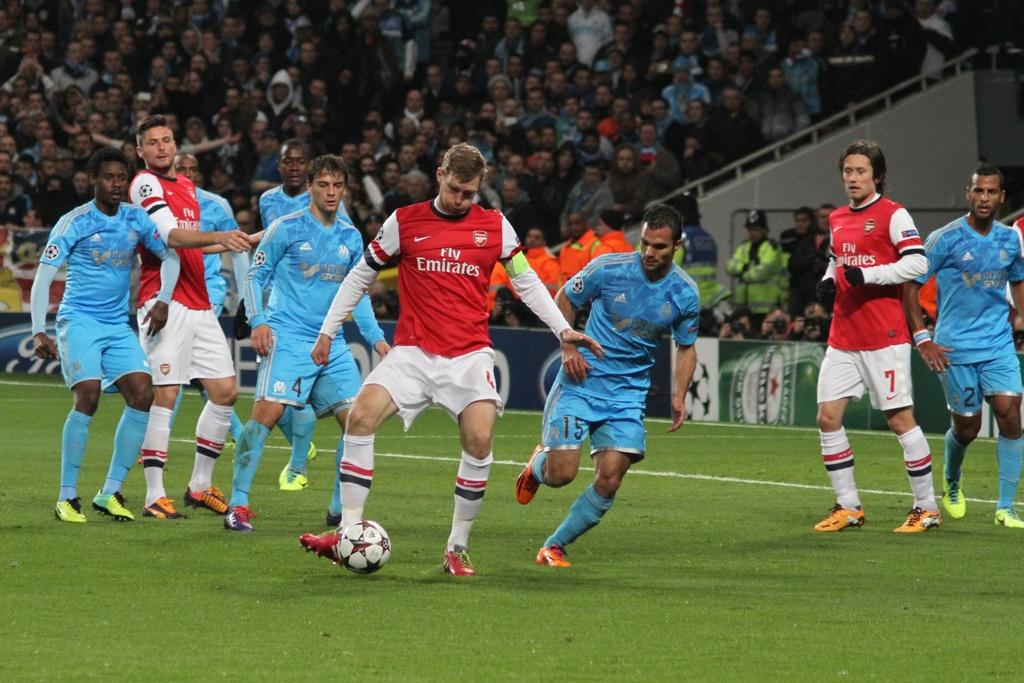<image>
Offer a succinct explanation of the picture presented. A soccer game is being played with the Emirates. 